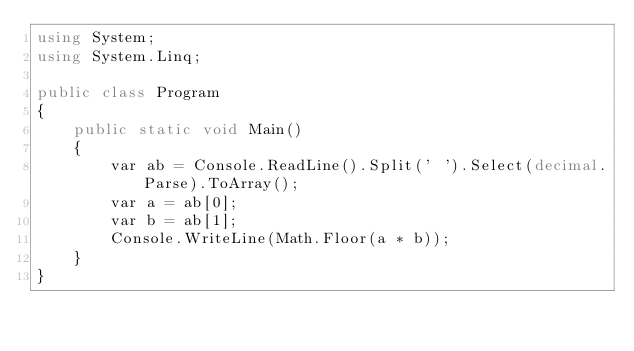Convert code to text. <code><loc_0><loc_0><loc_500><loc_500><_C#_>using System;
using System.Linq;

public class Program
{
    public static void Main() 
    {
        var ab = Console.ReadLine().Split(' ').Select(decimal.Parse).ToArray();
        var a = ab[0];
        var b = ab[1];
        Console.WriteLine(Math.Floor(a * b));
    }
}</code> 